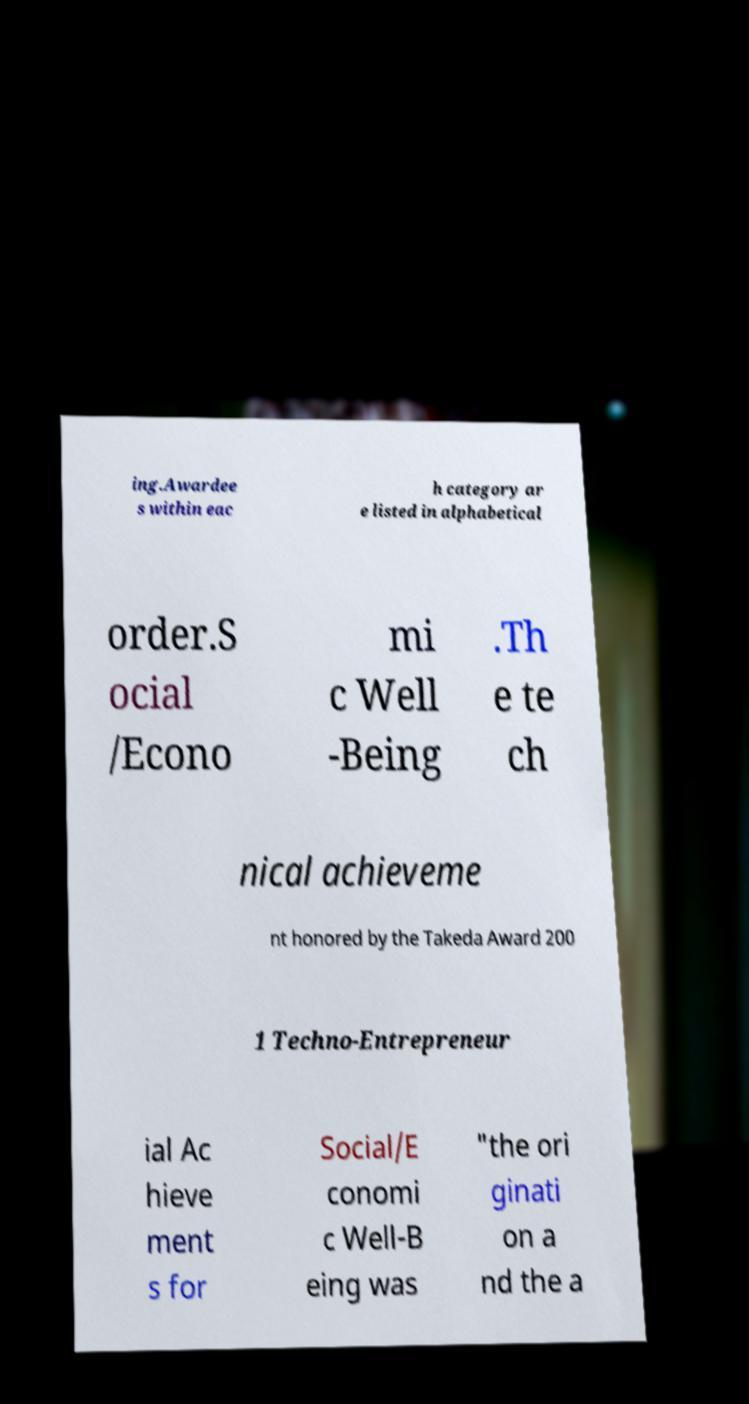Can you read and provide the text displayed in the image?This photo seems to have some interesting text. Can you extract and type it out for me? ing.Awardee s within eac h category ar e listed in alphabetical order.S ocial /Econo mi c Well -Being .Th e te ch nical achieveme nt honored by the Takeda Award 200 1 Techno-Entrepreneur ial Ac hieve ment s for Social/E conomi c Well-B eing was "the ori ginati on a nd the a 